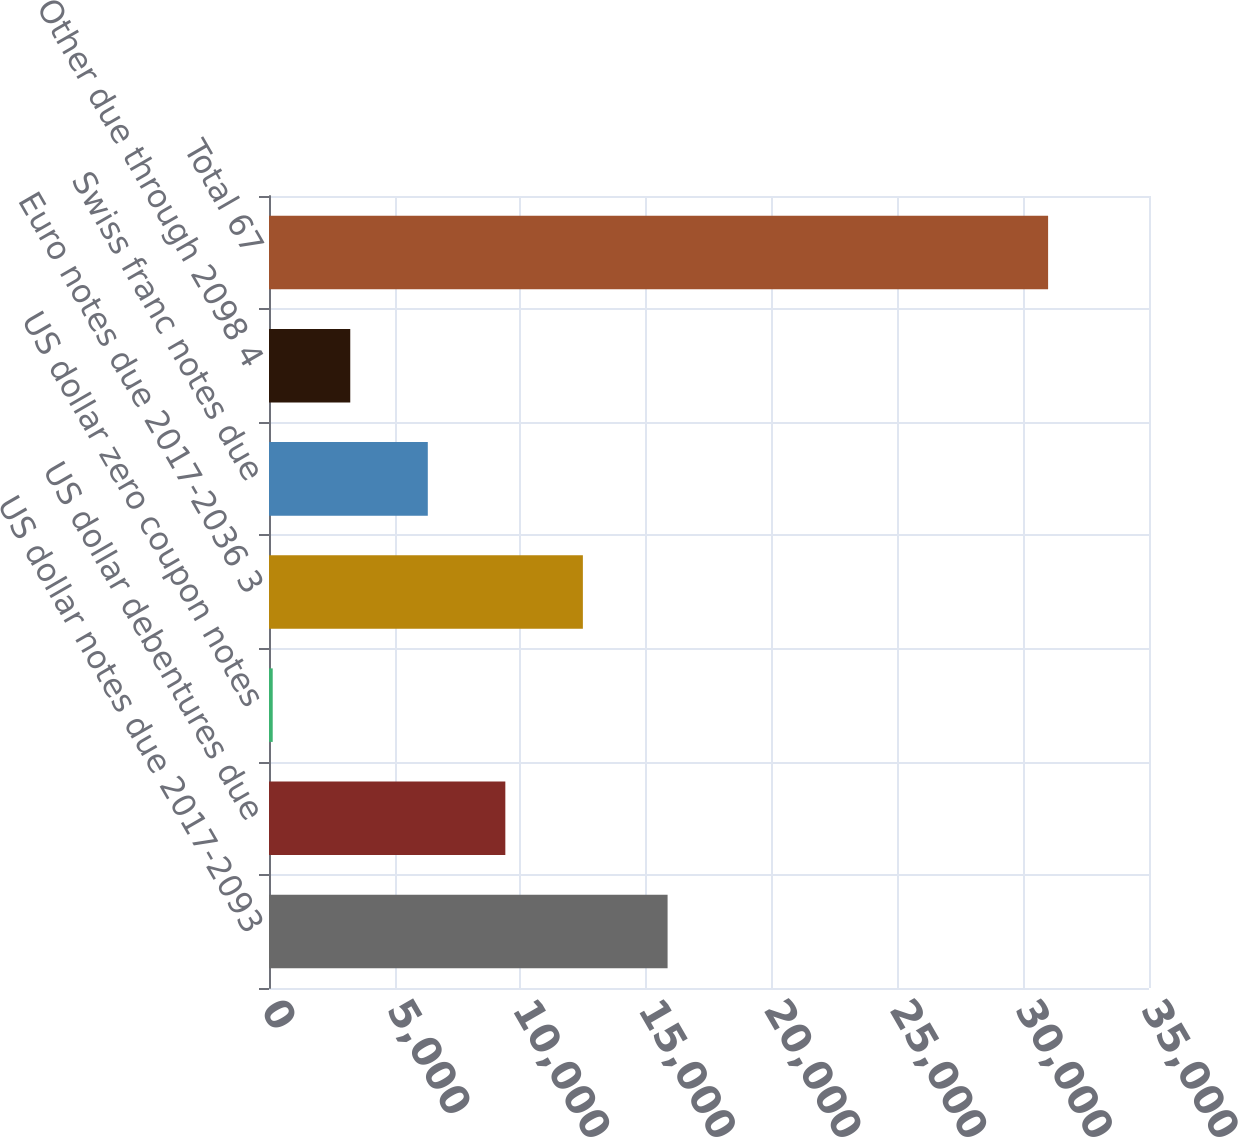Convert chart. <chart><loc_0><loc_0><loc_500><loc_500><bar_chart><fcel>US dollar notes due 2017-2093<fcel>US dollar debentures due<fcel>US dollar zero coupon notes<fcel>Euro notes due 2017-2036 3<fcel>Swiss franc notes due<fcel>Other due through 2098 4<fcel>Total 67<nl><fcel>15853<fcel>9399.7<fcel>148<fcel>12483.6<fcel>6315.8<fcel>3231.9<fcel>30987<nl></chart> 